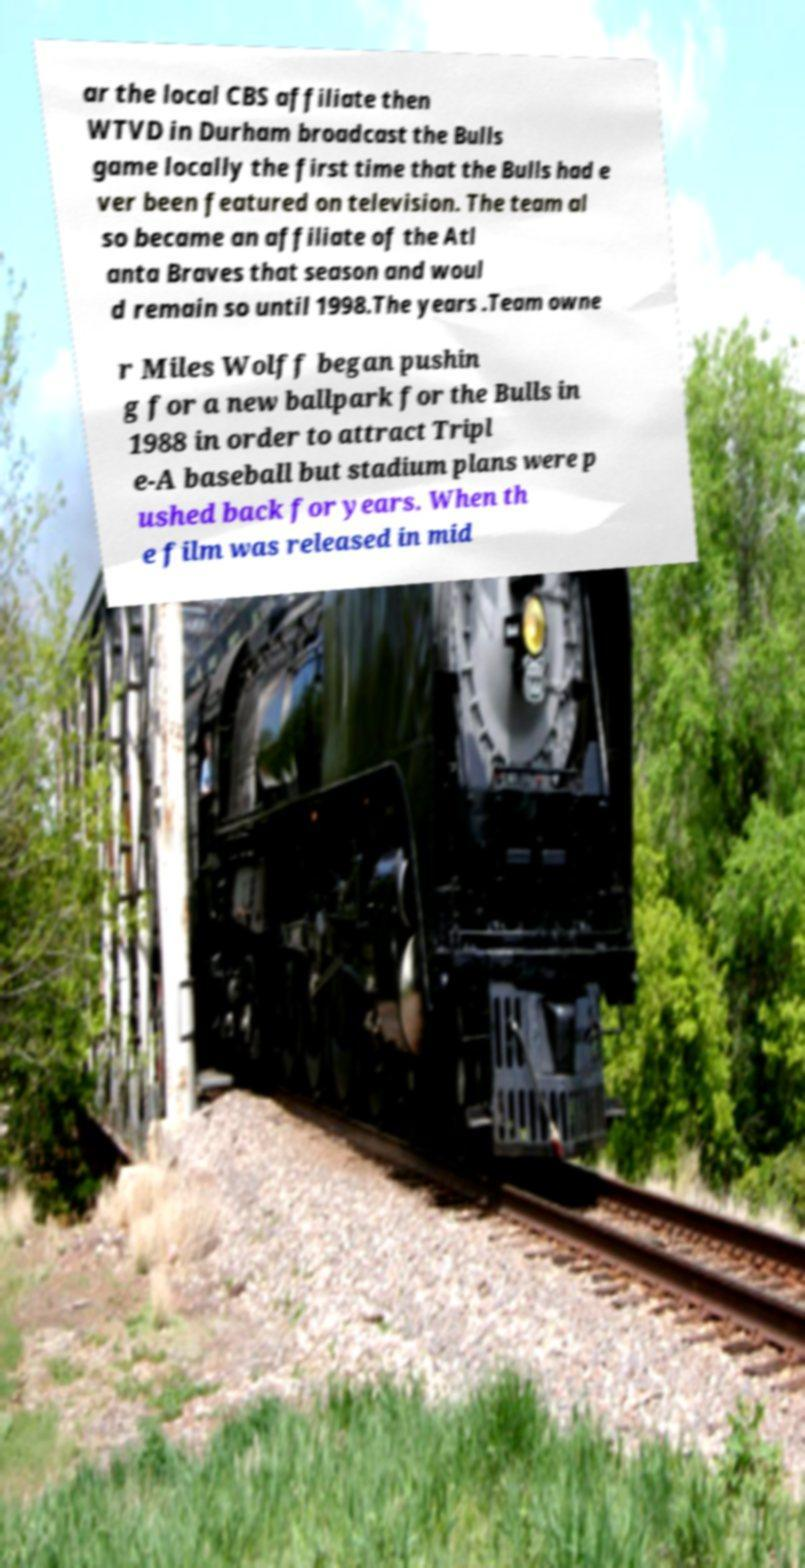For documentation purposes, I need the text within this image transcribed. Could you provide that? ar the local CBS affiliate then WTVD in Durham broadcast the Bulls game locally the first time that the Bulls had e ver been featured on television. The team al so became an affiliate of the Atl anta Braves that season and woul d remain so until 1998.The years .Team owne r Miles Wolff began pushin g for a new ballpark for the Bulls in 1988 in order to attract Tripl e-A baseball but stadium plans were p ushed back for years. When th e film was released in mid 